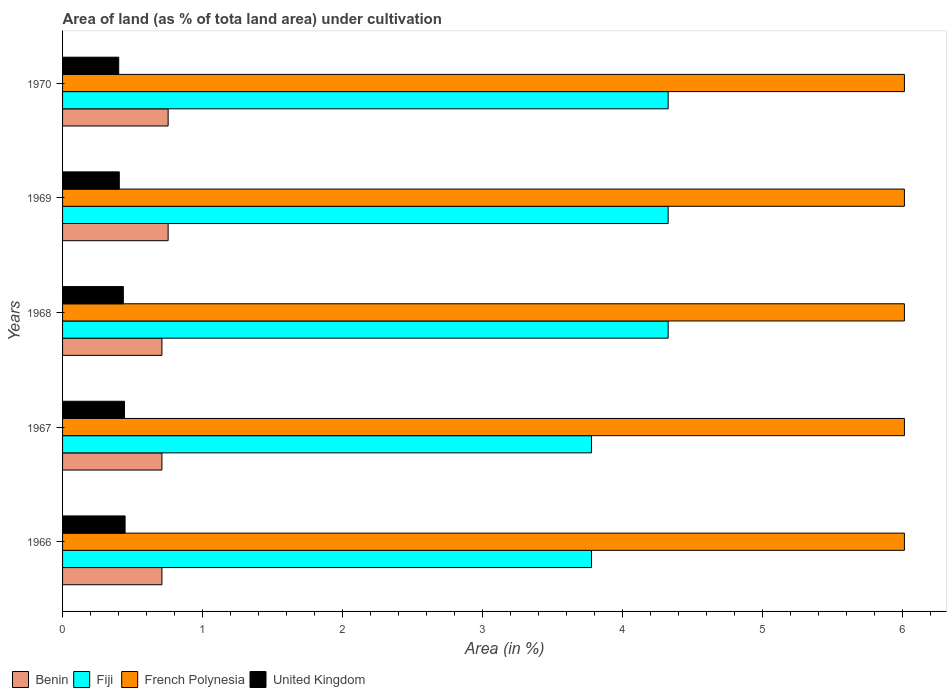How many groups of bars are there?
Make the answer very short. 5. Are the number of bars on each tick of the Y-axis equal?
Offer a terse response. Yes. What is the label of the 2nd group of bars from the top?
Provide a short and direct response. 1969. What is the percentage of land under cultivation in Fiji in 1967?
Your answer should be very brief. 3.78. Across all years, what is the maximum percentage of land under cultivation in Fiji?
Make the answer very short. 4.32. Across all years, what is the minimum percentage of land under cultivation in Benin?
Give a very brief answer. 0.71. In which year was the percentage of land under cultivation in Fiji maximum?
Provide a short and direct response. 1968. In which year was the percentage of land under cultivation in French Polynesia minimum?
Offer a very short reply. 1966. What is the total percentage of land under cultivation in Fiji in the graph?
Offer a very short reply. 20.53. What is the difference between the percentage of land under cultivation in French Polynesia in 1970 and the percentage of land under cultivation in United Kingdom in 1967?
Provide a short and direct response. 5.57. What is the average percentage of land under cultivation in French Polynesia per year?
Make the answer very short. 6.01. In the year 1968, what is the difference between the percentage of land under cultivation in Benin and percentage of land under cultivation in Fiji?
Keep it short and to the point. -3.61. In how many years, is the percentage of land under cultivation in French Polynesia greater than 6 %?
Your answer should be very brief. 5. What is the ratio of the percentage of land under cultivation in Benin in 1968 to that in 1969?
Offer a very short reply. 0.94. Is the percentage of land under cultivation in Fiji in 1967 less than that in 1969?
Provide a succinct answer. Yes. Is the difference between the percentage of land under cultivation in Benin in 1969 and 1970 greater than the difference between the percentage of land under cultivation in Fiji in 1969 and 1970?
Offer a terse response. No. What is the difference between the highest and the second highest percentage of land under cultivation in French Polynesia?
Your response must be concise. 0. What is the difference between the highest and the lowest percentage of land under cultivation in Fiji?
Offer a very short reply. 0.55. In how many years, is the percentage of land under cultivation in French Polynesia greater than the average percentage of land under cultivation in French Polynesia taken over all years?
Your response must be concise. 0. What does the 4th bar from the top in 1970 represents?
Give a very brief answer. Benin. What does the 2nd bar from the bottom in 1967 represents?
Provide a succinct answer. Fiji. Is it the case that in every year, the sum of the percentage of land under cultivation in Benin and percentage of land under cultivation in Fiji is greater than the percentage of land under cultivation in United Kingdom?
Ensure brevity in your answer.  Yes. How many bars are there?
Provide a short and direct response. 20. Are all the bars in the graph horizontal?
Provide a succinct answer. Yes. How many years are there in the graph?
Ensure brevity in your answer.  5. What is the difference between two consecutive major ticks on the X-axis?
Keep it short and to the point. 1. Are the values on the major ticks of X-axis written in scientific E-notation?
Your response must be concise. No. Does the graph contain any zero values?
Ensure brevity in your answer.  No. How many legend labels are there?
Give a very brief answer. 4. What is the title of the graph?
Keep it short and to the point. Area of land (as % of tota land area) under cultivation. Does "Philippines" appear as one of the legend labels in the graph?
Offer a terse response. No. What is the label or title of the X-axis?
Offer a very short reply. Area (in %). What is the Area (in %) in Benin in 1966?
Your answer should be compact. 0.71. What is the Area (in %) of Fiji in 1966?
Make the answer very short. 3.78. What is the Area (in %) of French Polynesia in 1966?
Ensure brevity in your answer.  6.01. What is the Area (in %) in United Kingdom in 1966?
Offer a terse response. 0.45. What is the Area (in %) of Benin in 1967?
Provide a succinct answer. 0.71. What is the Area (in %) in Fiji in 1967?
Ensure brevity in your answer.  3.78. What is the Area (in %) of French Polynesia in 1967?
Provide a succinct answer. 6.01. What is the Area (in %) in United Kingdom in 1967?
Offer a terse response. 0.44. What is the Area (in %) of Benin in 1968?
Make the answer very short. 0.71. What is the Area (in %) in Fiji in 1968?
Keep it short and to the point. 4.32. What is the Area (in %) in French Polynesia in 1968?
Your response must be concise. 6.01. What is the Area (in %) in United Kingdom in 1968?
Provide a succinct answer. 0.43. What is the Area (in %) in Benin in 1969?
Provide a short and direct response. 0.75. What is the Area (in %) in Fiji in 1969?
Your answer should be very brief. 4.32. What is the Area (in %) in French Polynesia in 1969?
Provide a short and direct response. 6.01. What is the Area (in %) of United Kingdom in 1969?
Offer a terse response. 0.41. What is the Area (in %) in Benin in 1970?
Your answer should be very brief. 0.75. What is the Area (in %) in Fiji in 1970?
Your response must be concise. 4.32. What is the Area (in %) in French Polynesia in 1970?
Keep it short and to the point. 6.01. What is the Area (in %) of United Kingdom in 1970?
Offer a very short reply. 0.4. Across all years, what is the maximum Area (in %) in Benin?
Offer a very short reply. 0.75. Across all years, what is the maximum Area (in %) of Fiji?
Offer a very short reply. 4.32. Across all years, what is the maximum Area (in %) in French Polynesia?
Provide a short and direct response. 6.01. Across all years, what is the maximum Area (in %) of United Kingdom?
Provide a short and direct response. 0.45. Across all years, what is the minimum Area (in %) of Benin?
Ensure brevity in your answer.  0.71. Across all years, what is the minimum Area (in %) in Fiji?
Provide a succinct answer. 3.78. Across all years, what is the minimum Area (in %) of French Polynesia?
Provide a succinct answer. 6.01. Across all years, what is the minimum Area (in %) of United Kingdom?
Ensure brevity in your answer.  0.4. What is the total Area (in %) in Benin in the graph?
Provide a succinct answer. 3.64. What is the total Area (in %) of Fiji in the graph?
Make the answer very short. 20.53. What is the total Area (in %) in French Polynesia in the graph?
Offer a very short reply. 30.05. What is the total Area (in %) of United Kingdom in the graph?
Offer a very short reply. 2.13. What is the difference between the Area (in %) of Benin in 1966 and that in 1967?
Keep it short and to the point. 0. What is the difference between the Area (in %) of French Polynesia in 1966 and that in 1967?
Make the answer very short. 0. What is the difference between the Area (in %) in United Kingdom in 1966 and that in 1967?
Provide a succinct answer. 0. What is the difference between the Area (in %) in Benin in 1966 and that in 1968?
Make the answer very short. 0. What is the difference between the Area (in %) of Fiji in 1966 and that in 1968?
Keep it short and to the point. -0.55. What is the difference between the Area (in %) of United Kingdom in 1966 and that in 1968?
Keep it short and to the point. 0.01. What is the difference between the Area (in %) of Benin in 1966 and that in 1969?
Offer a very short reply. -0.04. What is the difference between the Area (in %) in Fiji in 1966 and that in 1969?
Offer a terse response. -0.55. What is the difference between the Area (in %) in French Polynesia in 1966 and that in 1969?
Offer a very short reply. 0. What is the difference between the Area (in %) of United Kingdom in 1966 and that in 1969?
Provide a short and direct response. 0.04. What is the difference between the Area (in %) of Benin in 1966 and that in 1970?
Your answer should be compact. -0.04. What is the difference between the Area (in %) in Fiji in 1966 and that in 1970?
Your response must be concise. -0.55. What is the difference between the Area (in %) of French Polynesia in 1966 and that in 1970?
Offer a terse response. 0. What is the difference between the Area (in %) of United Kingdom in 1966 and that in 1970?
Ensure brevity in your answer.  0.05. What is the difference between the Area (in %) in Fiji in 1967 and that in 1968?
Your response must be concise. -0.55. What is the difference between the Area (in %) of United Kingdom in 1967 and that in 1968?
Keep it short and to the point. 0.01. What is the difference between the Area (in %) of Benin in 1967 and that in 1969?
Offer a terse response. -0.04. What is the difference between the Area (in %) of Fiji in 1967 and that in 1969?
Make the answer very short. -0.55. What is the difference between the Area (in %) of French Polynesia in 1967 and that in 1969?
Keep it short and to the point. 0. What is the difference between the Area (in %) of United Kingdom in 1967 and that in 1969?
Provide a short and direct response. 0.04. What is the difference between the Area (in %) in Benin in 1967 and that in 1970?
Provide a succinct answer. -0.04. What is the difference between the Area (in %) in Fiji in 1967 and that in 1970?
Give a very brief answer. -0.55. What is the difference between the Area (in %) of French Polynesia in 1967 and that in 1970?
Offer a very short reply. 0. What is the difference between the Area (in %) in United Kingdom in 1967 and that in 1970?
Offer a terse response. 0.04. What is the difference between the Area (in %) in Benin in 1968 and that in 1969?
Provide a short and direct response. -0.04. What is the difference between the Area (in %) of United Kingdom in 1968 and that in 1969?
Give a very brief answer. 0.03. What is the difference between the Area (in %) of Benin in 1968 and that in 1970?
Keep it short and to the point. -0.04. What is the difference between the Area (in %) of French Polynesia in 1968 and that in 1970?
Ensure brevity in your answer.  0. What is the difference between the Area (in %) of United Kingdom in 1968 and that in 1970?
Ensure brevity in your answer.  0.03. What is the difference between the Area (in %) of Fiji in 1969 and that in 1970?
Ensure brevity in your answer.  0. What is the difference between the Area (in %) of United Kingdom in 1969 and that in 1970?
Your answer should be compact. 0. What is the difference between the Area (in %) of Benin in 1966 and the Area (in %) of Fiji in 1967?
Your answer should be compact. -3.07. What is the difference between the Area (in %) of Benin in 1966 and the Area (in %) of French Polynesia in 1967?
Your response must be concise. -5.3. What is the difference between the Area (in %) of Benin in 1966 and the Area (in %) of United Kingdom in 1967?
Give a very brief answer. 0.27. What is the difference between the Area (in %) of Fiji in 1966 and the Area (in %) of French Polynesia in 1967?
Keep it short and to the point. -2.23. What is the difference between the Area (in %) of Fiji in 1966 and the Area (in %) of United Kingdom in 1967?
Offer a terse response. 3.33. What is the difference between the Area (in %) of French Polynesia in 1966 and the Area (in %) of United Kingdom in 1967?
Your response must be concise. 5.57. What is the difference between the Area (in %) in Benin in 1966 and the Area (in %) in Fiji in 1968?
Offer a very short reply. -3.61. What is the difference between the Area (in %) in Benin in 1966 and the Area (in %) in French Polynesia in 1968?
Give a very brief answer. -5.3. What is the difference between the Area (in %) of Benin in 1966 and the Area (in %) of United Kingdom in 1968?
Make the answer very short. 0.28. What is the difference between the Area (in %) in Fiji in 1966 and the Area (in %) in French Polynesia in 1968?
Ensure brevity in your answer.  -2.23. What is the difference between the Area (in %) of Fiji in 1966 and the Area (in %) of United Kingdom in 1968?
Offer a terse response. 3.34. What is the difference between the Area (in %) of French Polynesia in 1966 and the Area (in %) of United Kingdom in 1968?
Offer a very short reply. 5.58. What is the difference between the Area (in %) in Benin in 1966 and the Area (in %) in Fiji in 1969?
Make the answer very short. -3.61. What is the difference between the Area (in %) in Benin in 1966 and the Area (in %) in French Polynesia in 1969?
Your answer should be very brief. -5.3. What is the difference between the Area (in %) in Benin in 1966 and the Area (in %) in United Kingdom in 1969?
Your response must be concise. 0.3. What is the difference between the Area (in %) of Fiji in 1966 and the Area (in %) of French Polynesia in 1969?
Provide a short and direct response. -2.23. What is the difference between the Area (in %) of Fiji in 1966 and the Area (in %) of United Kingdom in 1969?
Ensure brevity in your answer.  3.37. What is the difference between the Area (in %) of French Polynesia in 1966 and the Area (in %) of United Kingdom in 1969?
Give a very brief answer. 5.61. What is the difference between the Area (in %) of Benin in 1966 and the Area (in %) of Fiji in 1970?
Your answer should be very brief. -3.61. What is the difference between the Area (in %) in Benin in 1966 and the Area (in %) in French Polynesia in 1970?
Keep it short and to the point. -5.3. What is the difference between the Area (in %) of Benin in 1966 and the Area (in %) of United Kingdom in 1970?
Make the answer very short. 0.31. What is the difference between the Area (in %) of Fiji in 1966 and the Area (in %) of French Polynesia in 1970?
Ensure brevity in your answer.  -2.23. What is the difference between the Area (in %) of Fiji in 1966 and the Area (in %) of United Kingdom in 1970?
Provide a short and direct response. 3.38. What is the difference between the Area (in %) of French Polynesia in 1966 and the Area (in %) of United Kingdom in 1970?
Your answer should be compact. 5.61. What is the difference between the Area (in %) in Benin in 1967 and the Area (in %) in Fiji in 1968?
Make the answer very short. -3.61. What is the difference between the Area (in %) in Benin in 1967 and the Area (in %) in French Polynesia in 1968?
Provide a short and direct response. -5.3. What is the difference between the Area (in %) in Benin in 1967 and the Area (in %) in United Kingdom in 1968?
Provide a short and direct response. 0.28. What is the difference between the Area (in %) of Fiji in 1967 and the Area (in %) of French Polynesia in 1968?
Make the answer very short. -2.23. What is the difference between the Area (in %) of Fiji in 1967 and the Area (in %) of United Kingdom in 1968?
Keep it short and to the point. 3.34. What is the difference between the Area (in %) in French Polynesia in 1967 and the Area (in %) in United Kingdom in 1968?
Provide a short and direct response. 5.58. What is the difference between the Area (in %) of Benin in 1967 and the Area (in %) of Fiji in 1969?
Offer a very short reply. -3.61. What is the difference between the Area (in %) in Benin in 1967 and the Area (in %) in French Polynesia in 1969?
Give a very brief answer. -5.3. What is the difference between the Area (in %) in Benin in 1967 and the Area (in %) in United Kingdom in 1969?
Keep it short and to the point. 0.3. What is the difference between the Area (in %) of Fiji in 1967 and the Area (in %) of French Polynesia in 1969?
Your answer should be very brief. -2.23. What is the difference between the Area (in %) in Fiji in 1967 and the Area (in %) in United Kingdom in 1969?
Provide a succinct answer. 3.37. What is the difference between the Area (in %) of French Polynesia in 1967 and the Area (in %) of United Kingdom in 1969?
Make the answer very short. 5.61. What is the difference between the Area (in %) of Benin in 1967 and the Area (in %) of Fiji in 1970?
Keep it short and to the point. -3.61. What is the difference between the Area (in %) in Benin in 1967 and the Area (in %) in French Polynesia in 1970?
Provide a succinct answer. -5.3. What is the difference between the Area (in %) of Benin in 1967 and the Area (in %) of United Kingdom in 1970?
Give a very brief answer. 0.31. What is the difference between the Area (in %) in Fiji in 1967 and the Area (in %) in French Polynesia in 1970?
Offer a terse response. -2.23. What is the difference between the Area (in %) in Fiji in 1967 and the Area (in %) in United Kingdom in 1970?
Your answer should be compact. 3.38. What is the difference between the Area (in %) of French Polynesia in 1967 and the Area (in %) of United Kingdom in 1970?
Offer a very short reply. 5.61. What is the difference between the Area (in %) in Benin in 1968 and the Area (in %) in Fiji in 1969?
Provide a short and direct response. -3.61. What is the difference between the Area (in %) in Benin in 1968 and the Area (in %) in French Polynesia in 1969?
Your answer should be compact. -5.3. What is the difference between the Area (in %) of Benin in 1968 and the Area (in %) of United Kingdom in 1969?
Provide a succinct answer. 0.3. What is the difference between the Area (in %) in Fiji in 1968 and the Area (in %) in French Polynesia in 1969?
Provide a short and direct response. -1.69. What is the difference between the Area (in %) in Fiji in 1968 and the Area (in %) in United Kingdom in 1969?
Provide a succinct answer. 3.92. What is the difference between the Area (in %) of French Polynesia in 1968 and the Area (in %) of United Kingdom in 1969?
Give a very brief answer. 5.61. What is the difference between the Area (in %) in Benin in 1968 and the Area (in %) in Fiji in 1970?
Your answer should be compact. -3.61. What is the difference between the Area (in %) of Benin in 1968 and the Area (in %) of French Polynesia in 1970?
Keep it short and to the point. -5.3. What is the difference between the Area (in %) in Benin in 1968 and the Area (in %) in United Kingdom in 1970?
Ensure brevity in your answer.  0.31. What is the difference between the Area (in %) of Fiji in 1968 and the Area (in %) of French Polynesia in 1970?
Provide a short and direct response. -1.69. What is the difference between the Area (in %) in Fiji in 1968 and the Area (in %) in United Kingdom in 1970?
Ensure brevity in your answer.  3.92. What is the difference between the Area (in %) in French Polynesia in 1968 and the Area (in %) in United Kingdom in 1970?
Your answer should be very brief. 5.61. What is the difference between the Area (in %) in Benin in 1969 and the Area (in %) in Fiji in 1970?
Provide a succinct answer. -3.57. What is the difference between the Area (in %) of Benin in 1969 and the Area (in %) of French Polynesia in 1970?
Give a very brief answer. -5.26. What is the difference between the Area (in %) in Benin in 1969 and the Area (in %) in United Kingdom in 1970?
Give a very brief answer. 0.35. What is the difference between the Area (in %) in Fiji in 1969 and the Area (in %) in French Polynesia in 1970?
Offer a very short reply. -1.69. What is the difference between the Area (in %) of Fiji in 1969 and the Area (in %) of United Kingdom in 1970?
Your answer should be compact. 3.92. What is the difference between the Area (in %) of French Polynesia in 1969 and the Area (in %) of United Kingdom in 1970?
Your answer should be compact. 5.61. What is the average Area (in %) in Benin per year?
Offer a very short reply. 0.73. What is the average Area (in %) of Fiji per year?
Provide a short and direct response. 4.11. What is the average Area (in %) of French Polynesia per year?
Your answer should be compact. 6.01. What is the average Area (in %) in United Kingdom per year?
Offer a terse response. 0.43. In the year 1966, what is the difference between the Area (in %) of Benin and Area (in %) of Fiji?
Give a very brief answer. -3.07. In the year 1966, what is the difference between the Area (in %) of Benin and Area (in %) of French Polynesia?
Give a very brief answer. -5.3. In the year 1966, what is the difference between the Area (in %) of Benin and Area (in %) of United Kingdom?
Provide a succinct answer. 0.26. In the year 1966, what is the difference between the Area (in %) in Fiji and Area (in %) in French Polynesia?
Provide a short and direct response. -2.23. In the year 1966, what is the difference between the Area (in %) in Fiji and Area (in %) in United Kingdom?
Your response must be concise. 3.33. In the year 1966, what is the difference between the Area (in %) in French Polynesia and Area (in %) in United Kingdom?
Give a very brief answer. 5.56. In the year 1967, what is the difference between the Area (in %) in Benin and Area (in %) in Fiji?
Provide a succinct answer. -3.07. In the year 1967, what is the difference between the Area (in %) in Benin and Area (in %) in French Polynesia?
Make the answer very short. -5.3. In the year 1967, what is the difference between the Area (in %) of Benin and Area (in %) of United Kingdom?
Provide a short and direct response. 0.27. In the year 1967, what is the difference between the Area (in %) in Fiji and Area (in %) in French Polynesia?
Ensure brevity in your answer.  -2.23. In the year 1967, what is the difference between the Area (in %) in Fiji and Area (in %) in United Kingdom?
Your response must be concise. 3.33. In the year 1967, what is the difference between the Area (in %) in French Polynesia and Area (in %) in United Kingdom?
Provide a succinct answer. 5.57. In the year 1968, what is the difference between the Area (in %) of Benin and Area (in %) of Fiji?
Keep it short and to the point. -3.61. In the year 1968, what is the difference between the Area (in %) in Benin and Area (in %) in French Polynesia?
Provide a succinct answer. -5.3. In the year 1968, what is the difference between the Area (in %) in Benin and Area (in %) in United Kingdom?
Offer a very short reply. 0.28. In the year 1968, what is the difference between the Area (in %) in Fiji and Area (in %) in French Polynesia?
Ensure brevity in your answer.  -1.69. In the year 1968, what is the difference between the Area (in %) of Fiji and Area (in %) of United Kingdom?
Your answer should be compact. 3.89. In the year 1968, what is the difference between the Area (in %) in French Polynesia and Area (in %) in United Kingdom?
Make the answer very short. 5.58. In the year 1969, what is the difference between the Area (in %) of Benin and Area (in %) of Fiji?
Keep it short and to the point. -3.57. In the year 1969, what is the difference between the Area (in %) of Benin and Area (in %) of French Polynesia?
Provide a short and direct response. -5.26. In the year 1969, what is the difference between the Area (in %) in Benin and Area (in %) in United Kingdom?
Give a very brief answer. 0.35. In the year 1969, what is the difference between the Area (in %) of Fiji and Area (in %) of French Polynesia?
Ensure brevity in your answer.  -1.69. In the year 1969, what is the difference between the Area (in %) in Fiji and Area (in %) in United Kingdom?
Your answer should be very brief. 3.92. In the year 1969, what is the difference between the Area (in %) of French Polynesia and Area (in %) of United Kingdom?
Ensure brevity in your answer.  5.61. In the year 1970, what is the difference between the Area (in %) in Benin and Area (in %) in Fiji?
Ensure brevity in your answer.  -3.57. In the year 1970, what is the difference between the Area (in %) in Benin and Area (in %) in French Polynesia?
Offer a terse response. -5.26. In the year 1970, what is the difference between the Area (in %) of Benin and Area (in %) of United Kingdom?
Offer a terse response. 0.35. In the year 1970, what is the difference between the Area (in %) of Fiji and Area (in %) of French Polynesia?
Provide a succinct answer. -1.69. In the year 1970, what is the difference between the Area (in %) of Fiji and Area (in %) of United Kingdom?
Provide a short and direct response. 3.92. In the year 1970, what is the difference between the Area (in %) of French Polynesia and Area (in %) of United Kingdom?
Your answer should be compact. 5.61. What is the ratio of the Area (in %) of Fiji in 1966 to that in 1967?
Provide a short and direct response. 1. What is the ratio of the Area (in %) of French Polynesia in 1966 to that in 1967?
Offer a terse response. 1. What is the ratio of the Area (in %) in United Kingdom in 1966 to that in 1967?
Your answer should be very brief. 1.01. What is the ratio of the Area (in %) in Fiji in 1966 to that in 1968?
Offer a terse response. 0.87. What is the ratio of the Area (in %) of French Polynesia in 1966 to that in 1968?
Make the answer very short. 1. What is the ratio of the Area (in %) in United Kingdom in 1966 to that in 1968?
Give a very brief answer. 1.03. What is the ratio of the Area (in %) in Benin in 1966 to that in 1969?
Offer a terse response. 0.94. What is the ratio of the Area (in %) of Fiji in 1966 to that in 1969?
Your answer should be very brief. 0.87. What is the ratio of the Area (in %) in French Polynesia in 1966 to that in 1969?
Your answer should be compact. 1. What is the ratio of the Area (in %) of United Kingdom in 1966 to that in 1969?
Make the answer very short. 1.1. What is the ratio of the Area (in %) in Benin in 1966 to that in 1970?
Provide a succinct answer. 0.94. What is the ratio of the Area (in %) in Fiji in 1966 to that in 1970?
Provide a short and direct response. 0.87. What is the ratio of the Area (in %) in French Polynesia in 1966 to that in 1970?
Your answer should be compact. 1. What is the ratio of the Area (in %) in United Kingdom in 1966 to that in 1970?
Offer a very short reply. 1.11. What is the ratio of the Area (in %) in Fiji in 1967 to that in 1968?
Ensure brevity in your answer.  0.87. What is the ratio of the Area (in %) of United Kingdom in 1967 to that in 1968?
Keep it short and to the point. 1.02. What is the ratio of the Area (in %) in Benin in 1967 to that in 1969?
Give a very brief answer. 0.94. What is the ratio of the Area (in %) in Fiji in 1967 to that in 1969?
Offer a terse response. 0.87. What is the ratio of the Area (in %) in French Polynesia in 1967 to that in 1969?
Offer a very short reply. 1. What is the ratio of the Area (in %) of United Kingdom in 1967 to that in 1969?
Ensure brevity in your answer.  1.09. What is the ratio of the Area (in %) of Benin in 1967 to that in 1970?
Provide a succinct answer. 0.94. What is the ratio of the Area (in %) of Fiji in 1967 to that in 1970?
Offer a very short reply. 0.87. What is the ratio of the Area (in %) in United Kingdom in 1967 to that in 1970?
Your response must be concise. 1.1. What is the ratio of the Area (in %) of Fiji in 1968 to that in 1969?
Make the answer very short. 1. What is the ratio of the Area (in %) of United Kingdom in 1968 to that in 1969?
Make the answer very short. 1.07. What is the ratio of the Area (in %) of Benin in 1968 to that in 1970?
Provide a succinct answer. 0.94. What is the ratio of the Area (in %) of United Kingdom in 1968 to that in 1970?
Offer a terse response. 1.08. What is the ratio of the Area (in %) of Benin in 1969 to that in 1970?
Provide a short and direct response. 1. What is the ratio of the Area (in %) in Fiji in 1969 to that in 1970?
Your response must be concise. 1. What is the ratio of the Area (in %) of French Polynesia in 1969 to that in 1970?
Give a very brief answer. 1. What is the ratio of the Area (in %) in United Kingdom in 1969 to that in 1970?
Provide a succinct answer. 1.01. What is the difference between the highest and the second highest Area (in %) of Fiji?
Your answer should be compact. 0. What is the difference between the highest and the second highest Area (in %) in French Polynesia?
Provide a succinct answer. 0. What is the difference between the highest and the second highest Area (in %) in United Kingdom?
Provide a succinct answer. 0. What is the difference between the highest and the lowest Area (in %) in Benin?
Your answer should be compact. 0.04. What is the difference between the highest and the lowest Area (in %) of Fiji?
Offer a terse response. 0.55. What is the difference between the highest and the lowest Area (in %) in French Polynesia?
Offer a very short reply. 0. What is the difference between the highest and the lowest Area (in %) in United Kingdom?
Offer a very short reply. 0.05. 